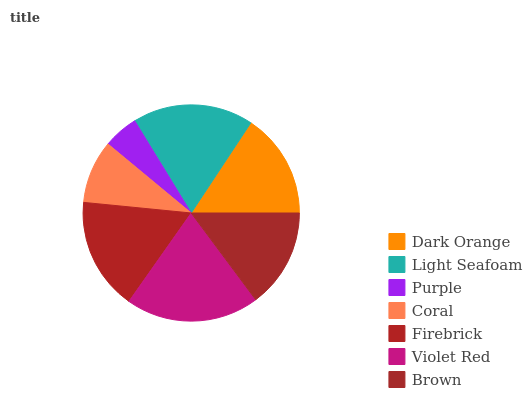Is Purple the minimum?
Answer yes or no. Yes. Is Violet Red the maximum?
Answer yes or no. Yes. Is Light Seafoam the minimum?
Answer yes or no. No. Is Light Seafoam the maximum?
Answer yes or no. No. Is Light Seafoam greater than Dark Orange?
Answer yes or no. Yes. Is Dark Orange less than Light Seafoam?
Answer yes or no. Yes. Is Dark Orange greater than Light Seafoam?
Answer yes or no. No. Is Light Seafoam less than Dark Orange?
Answer yes or no. No. Is Dark Orange the high median?
Answer yes or no. Yes. Is Dark Orange the low median?
Answer yes or no. Yes. Is Brown the high median?
Answer yes or no. No. Is Firebrick the low median?
Answer yes or no. No. 